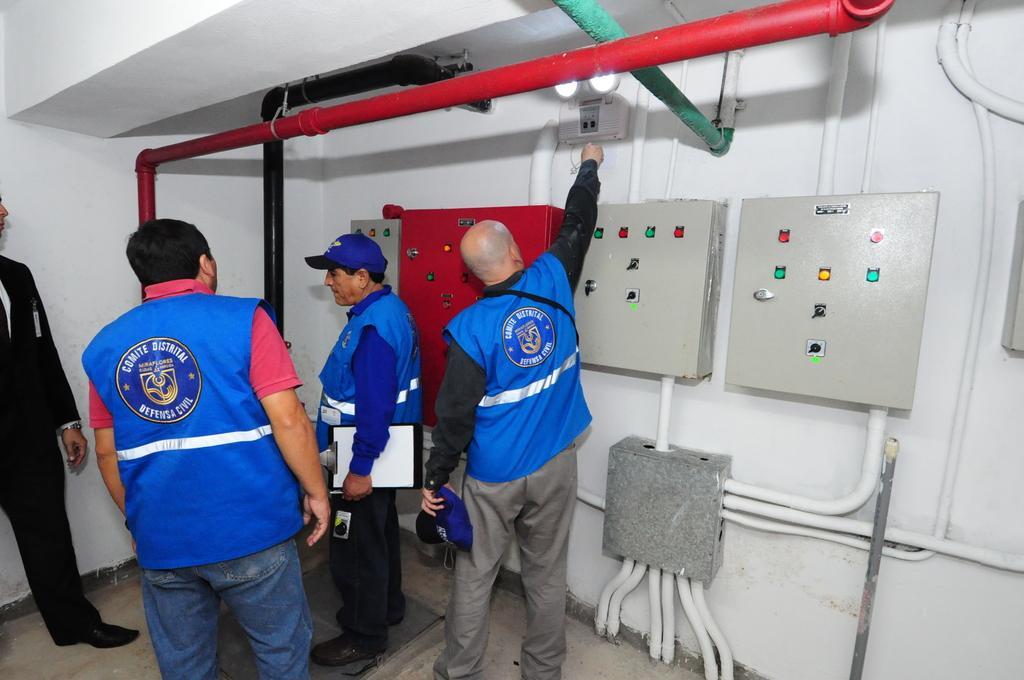Describe this image in one or two sentences. In this image, I can see four persons standing on the floor. There are iron pipes, junction box and panel boards are attached to the wall. 